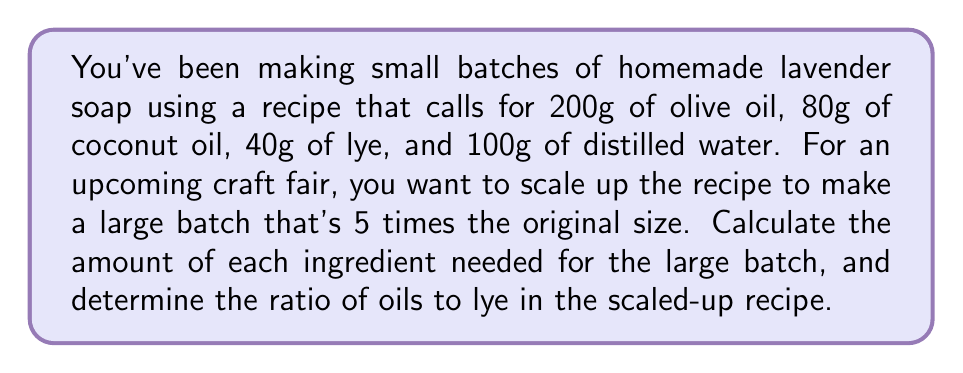Help me with this question. To solve this problem, we'll follow these steps:

1. Scale up each ingredient by multiplying the original amount by 5.
2. Calculate the total amount of oils in the large batch.
3. Determine the ratio of oils to lye.

Step 1: Scaling up ingredients

For each ingredient, we multiply the original amount by 5:

Olive oil: $200g \times 5 = 1000g$
Coconut oil: $80g \times 5 = 400g$
Lye: $40g \times 5 = 200g$
Distilled water: $100g \times 5 = 500g$

Step 2: Calculate total amount of oils

Total oils = Olive oil + Coconut oil
$$Total oils = 1000g + 400g = 1400g$$

Step 3: Determine the ratio of oils to lye

To find the ratio, we divide the total amount of oils by the amount of lye:

$$Ratio = \frac{Total oils}{Lye} = \frac{1400g}{200g} = 7:1$$

This means for every 7 parts of oils, there is 1 part of lye in the recipe.

To express this as a simplified ratio, we divide both numbers by their greatest common divisor (GCD), which is 1 in this case. So, the final ratio remains 7:1.
Answer: The scaled-up recipe requires 1000g of olive oil, 400g of coconut oil, 200g of lye, and 500g of distilled water. The ratio of oils to lye in the large batch is 7:1. 